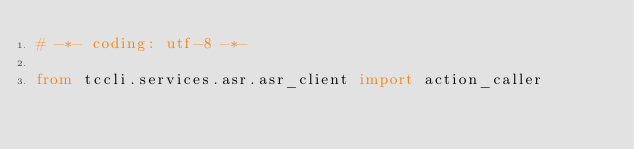Convert code to text. <code><loc_0><loc_0><loc_500><loc_500><_Python_># -*- coding: utf-8 -*-

from tccli.services.asr.asr_client import action_caller
    </code> 